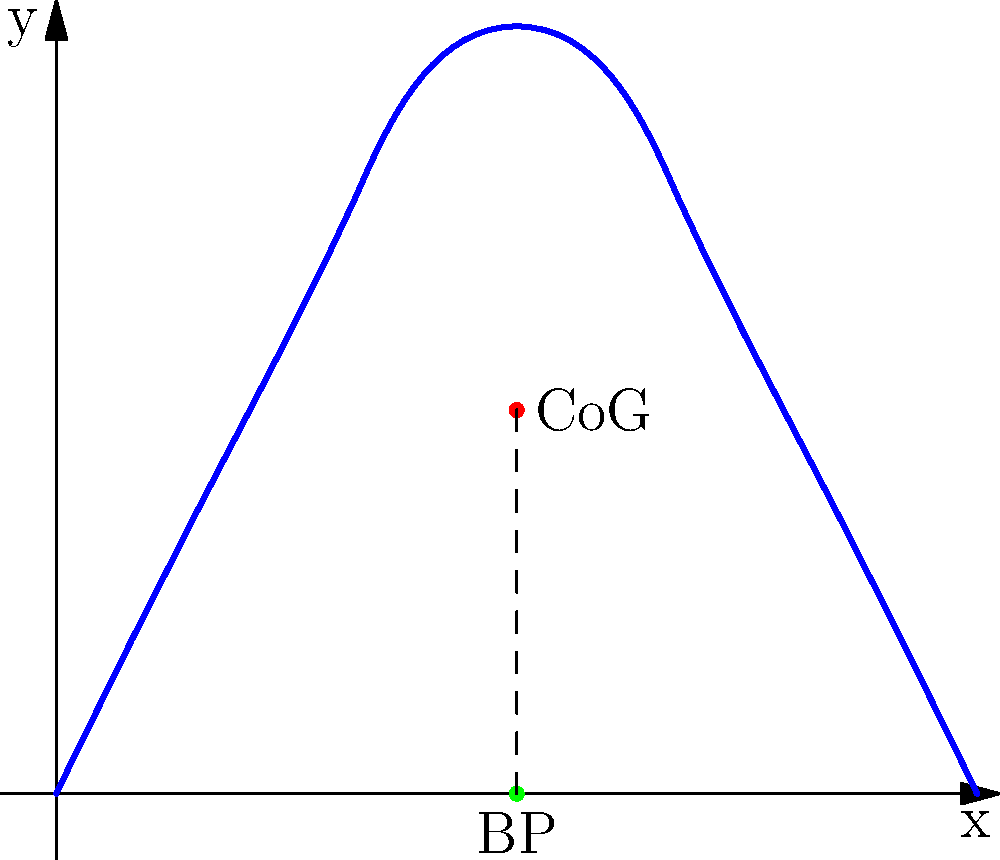In a ballet pose, the center of gravity (CoG) of a dancer is located directly above their balance point (BP). If the horizontal distance between the CoG and BP increases, how does this affect the stability of the pose? Explain using the principles of torque and moment arm. To understand the stability of a ballet pose, we need to consider the principles of torque and moment arm:

1. Torque ($\tau$) is the rotational force that causes an object to rotate around an axis. It is calculated as:

   $$ \tau = F \cdot d $$

   where $F$ is the force (in this case, the dancer's weight) and $d$ is the perpendicular distance from the axis of rotation to the line of action of the force (moment arm).

2. In a stable pose, the dancer's center of gravity (CoG) should be directly above the balance point (BP). This minimizes the moment arm and, consequently, the torque.

3. If the horizontal distance between the CoG and BP increases:
   a) The moment arm ($d$) increases.
   b) The torque ($\tau$) increases proportionally to the moment arm.

4. The increased torque makes it more difficult for the dancer to maintain balance, as there is a greater rotational force trying to topple the dancer.

5. To counteract this increased torque, the dancer must exert more muscular effort to maintain the pose, which reduces stability and makes the pose more challenging to hold.

6. The relationship between stability and horizontal displacement of CoG from BP can be expressed mathematically:

   $$ \text{Stability} \propto \frac{1}{d} $$

   where $d$ is the horizontal distance between CoG and BP.

In conclusion, as the horizontal distance between the CoG and BP increases, the stability of the pose decreases due to the increased torque acting on the dancer's body.
Answer: Stability decreases as horizontal distance between CoG and BP increases, due to increased torque. 